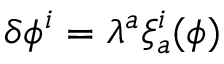Convert formula to latex. <formula><loc_0><loc_0><loc_500><loc_500>\delta \phi ^ { i } = \lambda ^ { a } \xi _ { a } ^ { i } ( \phi )</formula> 